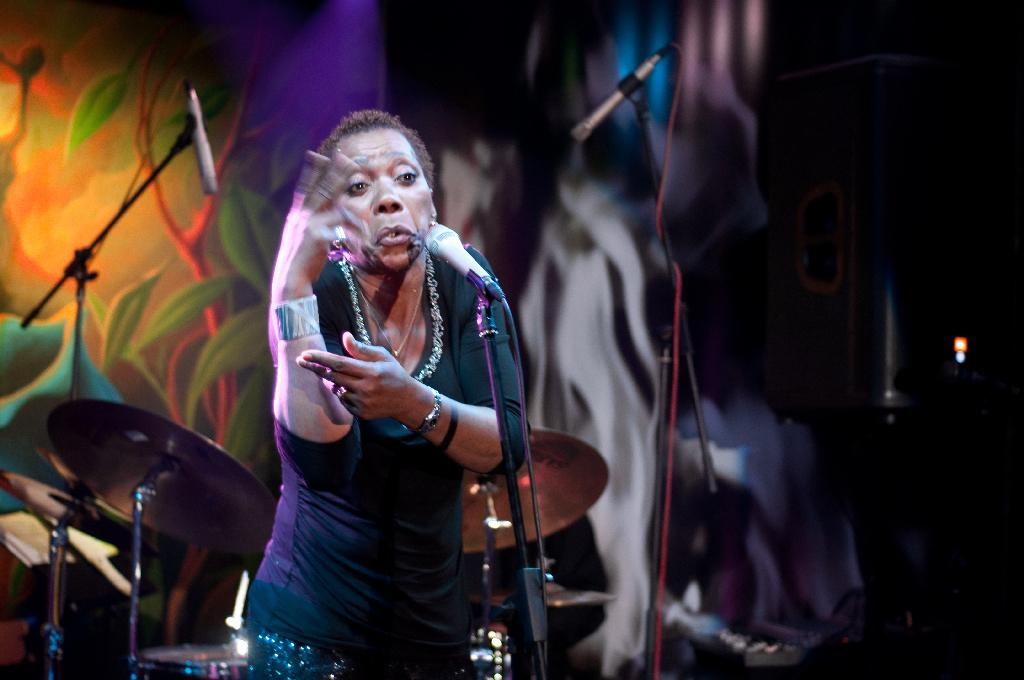What is the person in the image wearing? The person is wearing a black dress. What objects are present in the image that are related to sound production? There are microphones, microphone stands, and drums in the image. What type of sign can be seen hanging from the ceiling in the image? There is no sign hanging from the ceiling in the image; it only features a person wearing a black dress and various sound production equipment. 